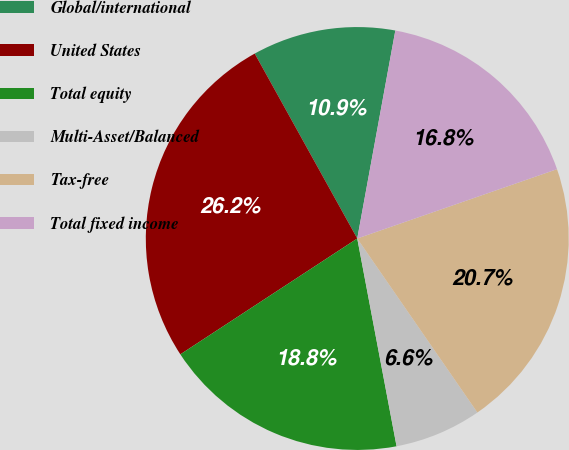Convert chart to OTSL. <chart><loc_0><loc_0><loc_500><loc_500><pie_chart><fcel>Global/international<fcel>United States<fcel>Total equity<fcel>Multi-Asset/Balanced<fcel>Tax-free<fcel>Total fixed income<nl><fcel>10.94%<fcel>26.17%<fcel>18.75%<fcel>6.64%<fcel>20.7%<fcel>16.8%<nl></chart> 